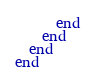Convert code to text. <code><loc_0><loc_0><loc_500><loc_500><_Ruby_>      end
    end
  end
end
</code> 